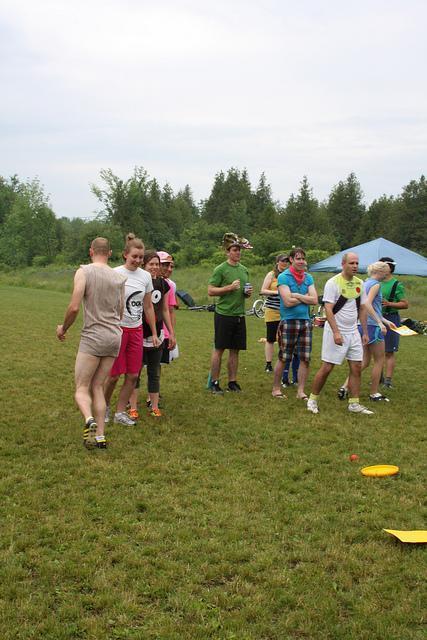Where are they playing a game?
Make your selection from the four choices given to correctly answer the question.
Options: Beach, park, stadium, gym. Park. 